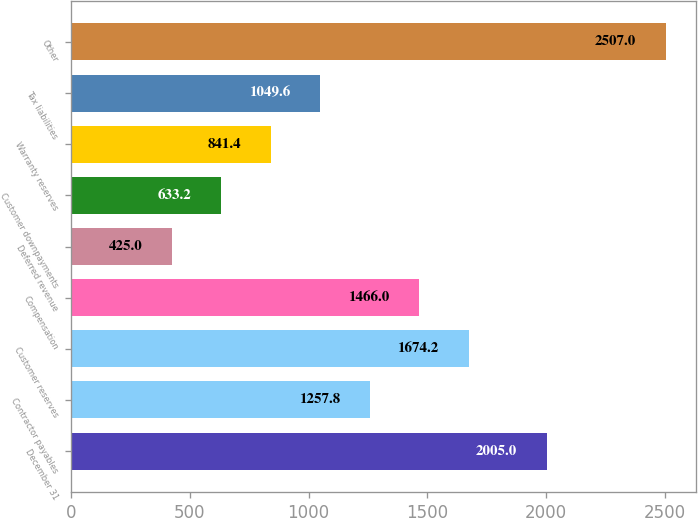Convert chart to OTSL. <chart><loc_0><loc_0><loc_500><loc_500><bar_chart><fcel>December 31<fcel>Contractor payables<fcel>Customer reserves<fcel>Compensation<fcel>Deferred revenue<fcel>Customer downpayments<fcel>Warranty reserves<fcel>Tax liabilities<fcel>Other<nl><fcel>2005<fcel>1257.8<fcel>1674.2<fcel>1466<fcel>425<fcel>633.2<fcel>841.4<fcel>1049.6<fcel>2507<nl></chart> 